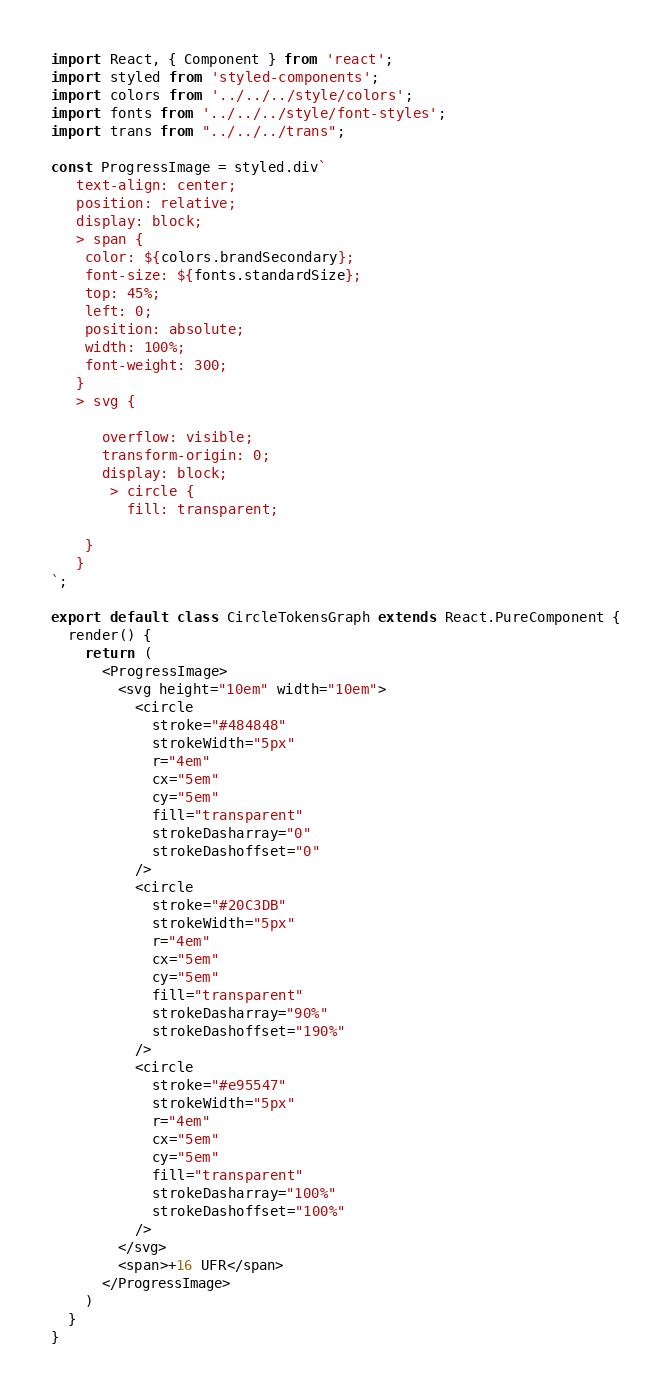<code> <loc_0><loc_0><loc_500><loc_500><_JavaScript_>import React, { Component } from 'react';
import styled from 'styled-components';
import colors from '../../../style/colors';
import fonts from '../../../style/font-styles';
import trans from "../../../trans";

const ProgressImage = styled.div`
   text-align: center;
   position: relative;
   display: block;
   > span {
    color: ${colors.brandSecondary};
    font-size: ${fonts.standardSize};
    top: 45%;
    left: 0;
    position: absolute;
    width: 100%;
    font-weight: 300;
   }
   > svg {
       
      overflow: visible;
      transform-origin: 0;
      display: block;
       > circle {
         fill: transparent;
         
    }
   }
`;

export default class CircleTokensGraph extends React.PureComponent {
  render() {
    return (
      <ProgressImage>
        <svg height="10em" width="10em">
          <circle
            stroke="#484848"
            strokeWidth="5px"
            r="4em"
            cx="5em"
            cy="5em"
            fill="transparent"
            strokeDasharray="0"
            strokeDashoffset="0"
          />
          <circle
            stroke="#20C3DB"
            strokeWidth="5px"
            r="4em"
            cx="5em"
            cy="5em"
            fill="transparent"
            strokeDasharray="90%"
            strokeDashoffset="190%"
          />
          <circle
            stroke="#e95547"
            strokeWidth="5px"
            r="4em"
            cx="5em"
            cy="5em"
            fill="transparent"
            strokeDasharray="100%"
            strokeDashoffset="100%"
          />
        </svg>
        <span>+16 UFR</span>
      </ProgressImage>
    )
  }
}



</code> 